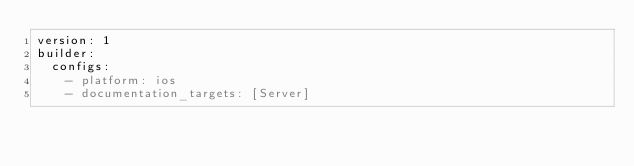<code> <loc_0><loc_0><loc_500><loc_500><_YAML_>version: 1
builder:
  configs:
    - platform: ios
    - documentation_targets: [Server]
</code> 